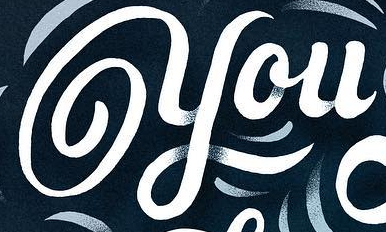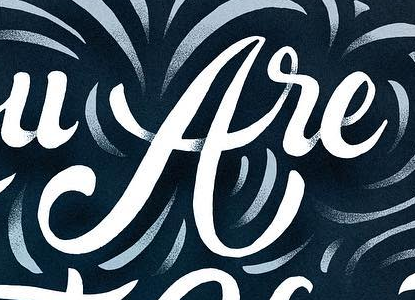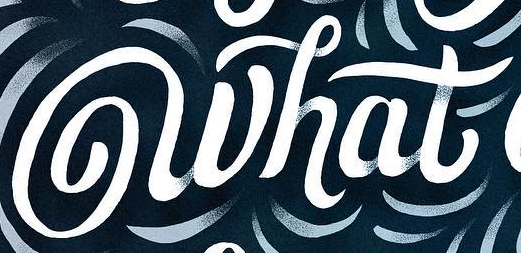What words are shown in these images in order, separated by a semicolon? you; are; what 